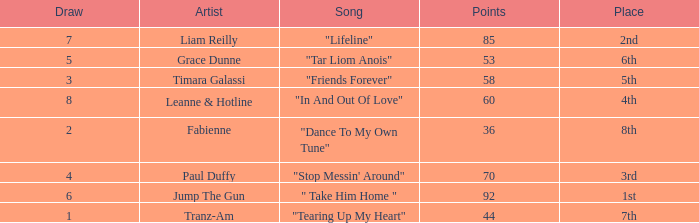What's the average draw for the song "stop messin' around"? 4.0. 